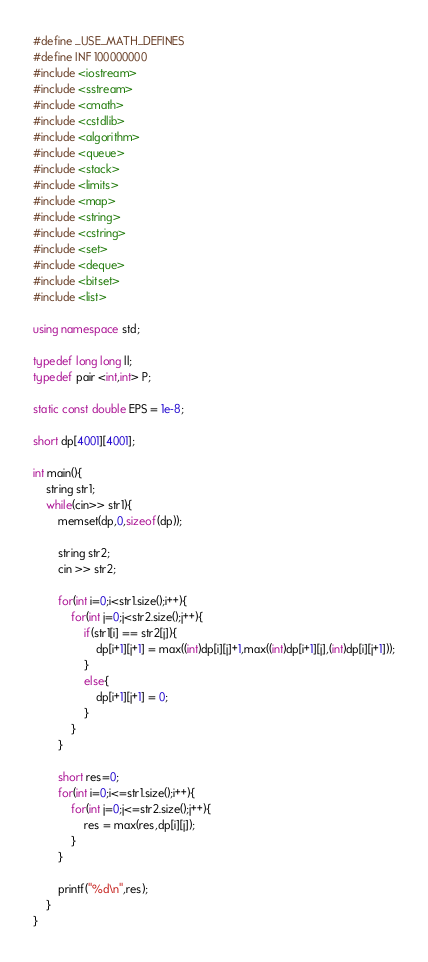<code> <loc_0><loc_0><loc_500><loc_500><_C++_>#define _USE_MATH_DEFINES
#define INF 100000000
#include <iostream>
#include <sstream>
#include <cmath>
#include <cstdlib>
#include <algorithm>
#include <queue>
#include <stack>
#include <limits>
#include <map>
#include <string>
#include <cstring>
#include <set>
#include <deque>
#include <bitset>
#include <list>

using namespace std;

typedef long long ll;
typedef pair <int,int> P;

static const double EPS = 1e-8;

short dp[4001][4001];

int main(){
	string str1;
	while(cin>> str1){
		memset(dp,0,sizeof(dp));

		string str2;
		cin >> str2;

		for(int i=0;i<str1.size();i++){
			for(int j=0;j<str2.size();j++){
				if(str1[i] == str2[j]){
					dp[i+1][j+1] = max((int)dp[i][j]+1,max((int)dp[i+1][j],(int)dp[i][j+1]));
				}
				else{
					dp[i+1][j+1] = 0;
				}
			}
		}

		short res=0;
		for(int i=0;i<=str1.size();i++){
			for(int j=0;j<=str2.size();j++){
				res = max(res,dp[i][j]);
			}
		}

		printf("%d\n",res);
	}
}</code> 